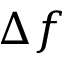Convert formula to latex. <formula><loc_0><loc_0><loc_500><loc_500>\Delta f</formula> 